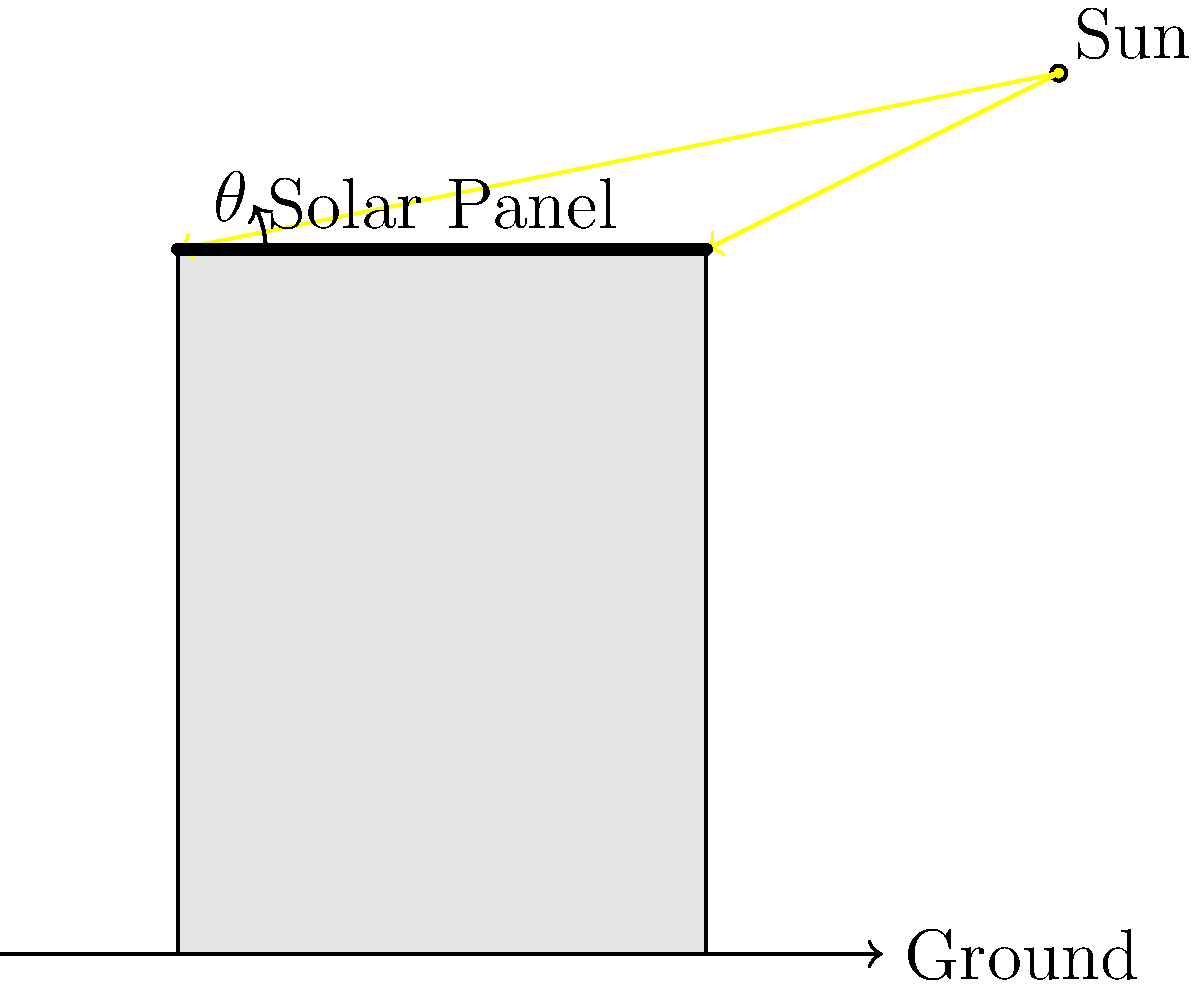As the Public Relations Officer for Winnipeg's city planning department, you're preparing a statement about the city's new solar energy initiative. The optimal angle for solar panels on flat-roofed buildings in Winnipeg is determined by the city's latitude. Given that Winnipeg's latitude is approximately 50°N, what is the recommended tilt angle $\theta$ for solar panels to maximize energy efficiency throughout the year? To determine the optimal tilt angle for solar panels in Winnipeg, we need to consider the following steps:

1. The general rule of thumb for fixed solar panels is that the optimal tilt angle is approximately equal to the latitude of the location.

2. Winnipeg's latitude is given as 50°N.

3. However, this rule is often adjusted slightly for year-round optimization:
   - For year-round use, the optimal angle is typically latitude minus 15°.
   - This adjustment helps to capture more energy during summer months when the sun is higher in the sky.

4. Calculate the recommended tilt angle:
   $\theta = 50° - 15° = 35°$

5. This angle provides a good compromise between summer and winter sun positions, maximizing overall annual energy production.

6. It's worth noting that this is a general recommendation. Factors such as local weather patterns, surrounding buildings, and specific energy needs might lead to slight adjustments in the actual implementation.
Answer: 35° 